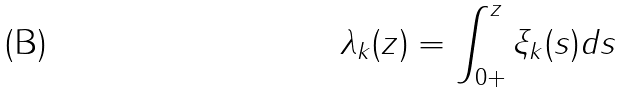Convert formula to latex. <formula><loc_0><loc_0><loc_500><loc_500>\lambda _ { k } ( z ) = \int _ { 0 + } ^ { z } \xi _ { k } ( s ) d s</formula> 